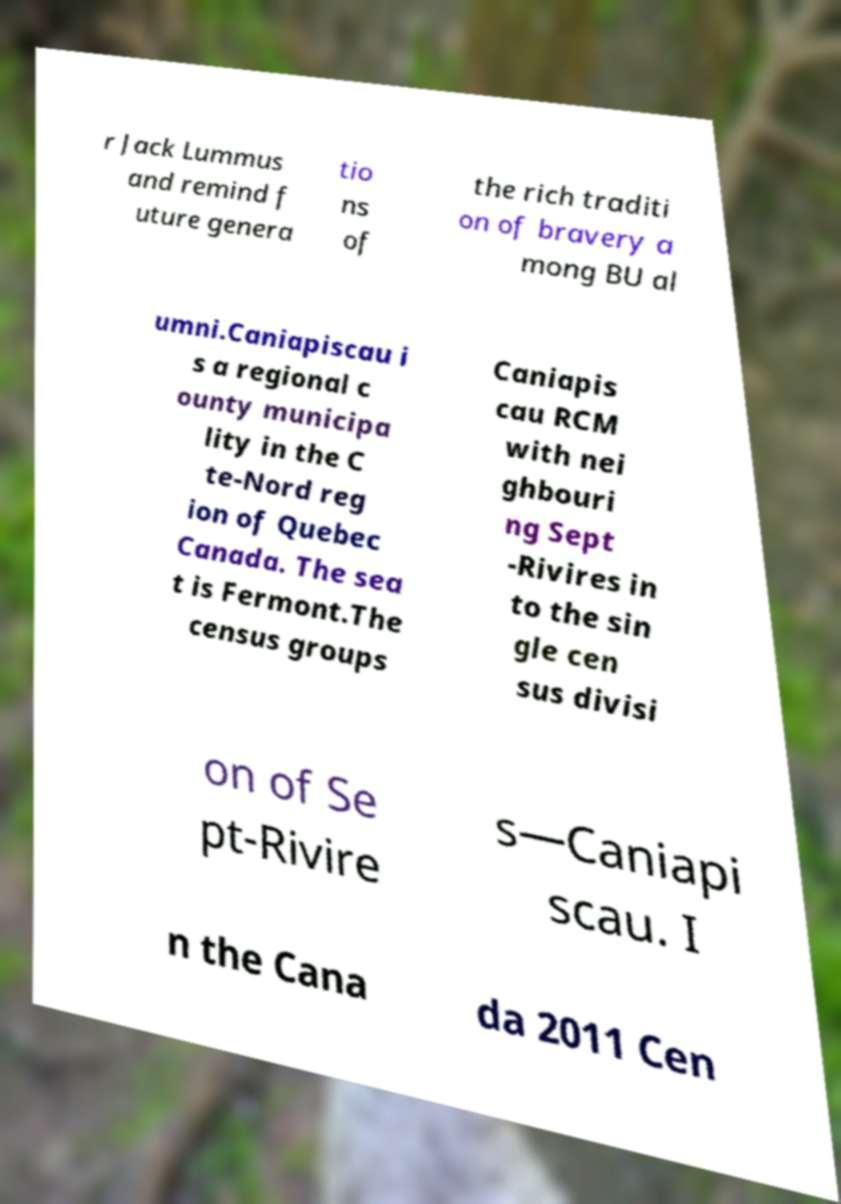For documentation purposes, I need the text within this image transcribed. Could you provide that? r Jack Lummus and remind f uture genera tio ns of the rich traditi on of bravery a mong BU al umni.Caniapiscau i s a regional c ounty municipa lity in the C te-Nord reg ion of Quebec Canada. The sea t is Fermont.The census groups Caniapis cau RCM with nei ghbouri ng Sept -Rivires in to the sin gle cen sus divisi on of Se pt-Rivire s—Caniapi scau. I n the Cana da 2011 Cen 